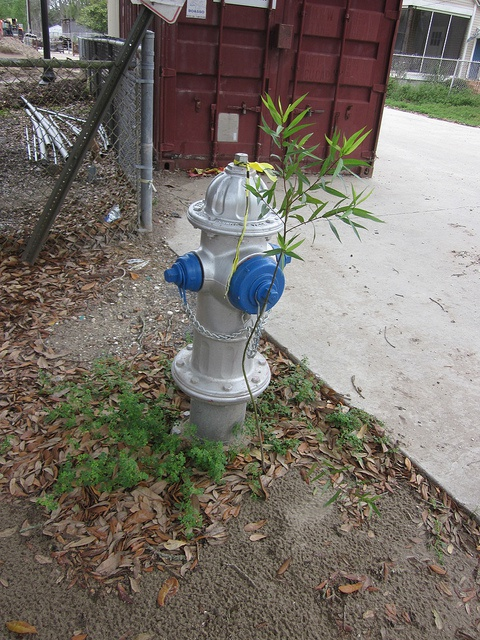Describe the objects in this image and their specific colors. I can see a fire hydrant in green, gray, darkgray, lightgray, and blue tones in this image. 